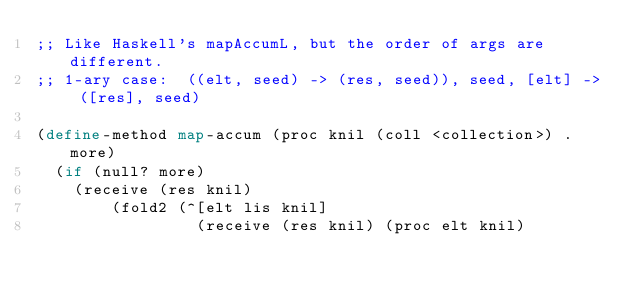Convert code to text. <code><loc_0><loc_0><loc_500><loc_500><_Scheme_>;; Like Haskell's mapAccumL, but the order of args are different.
;; 1-ary case:  ((elt, seed) -> (res, seed)), seed, [elt] -> ([res], seed)

(define-method map-accum (proc knil (coll <collection>) . more)
  (if (null? more)
    (receive (res knil)
        (fold2 (^[elt lis knil]
                 (receive (res knil) (proc elt knil)</code> 